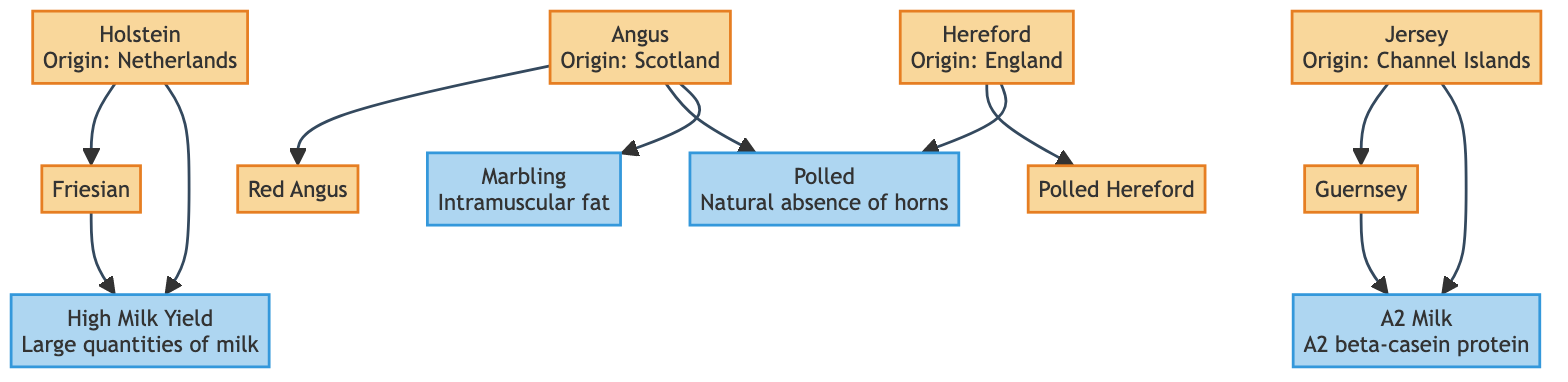What is the origin of Angus? The diagram specifies that Angus originates from Scotland. Therefore, by looking directly at the Angus node, we find "Scotland" listed as the origin.
Answer: Scotland Which breed is related to Holstein? According to the diagram, Holstein is related to Friesian, which is explicitly represented as a direct connection from Holstein to Friesian.
Answer: Friesian How many breeds have the genetic trait "Polled"? The "Polled" trait is associated with two breeds, which are Angus and Hereford. Therefore, counting the breeds directly connected to the Polled trait, we find two.
Answer: 2 What are the traits of Jersey? The diagram shows two traits associated with Jersey: "Rich milk content" and "Small size." By inspecting the Jersey node, we can identify these traits directly.
Answer: Rich milk content, Small size Which genetic trait is associated with Angus that improves meat quality? The diagram indicates that the trait "Marbling" is associated with Angus, specifically noted for contributing to better meat quality. Thus, we look for the connection from Angus to Marbling.
Answer: Marbling Which breed, related to Hereford, doesn't have horns? The diagram specifies that the trait "Polled", indicating the absence of horns, is associated with Hereford as well as Angus. The related breed to Hereford that is polled is "Polled Hereford", which is directly linked to Hereford.
Answer: Polled Hereford Which breed is known for high milk yield? By examining the trait "High Milk Yield" in the diagram, we see it is associated with Holstein and Friesian. Thus, we can identify that Holstein is one of those breeds known for this trait.
Answer: Holstein How many breeds are linked to the genetic trait A2 Milk? The A2 Milk genetic trait is associated with two breeds: Jersey and Guernsey. By checking the connections from A2 Milk, we can see both breeds are directly connected.
Answer: 2 Which breed originated from England? The diagram directly states that Hereford originated from England, as indicated in the Hereford node. Therefore, we look to this node for the information.
Answer: Hereford 